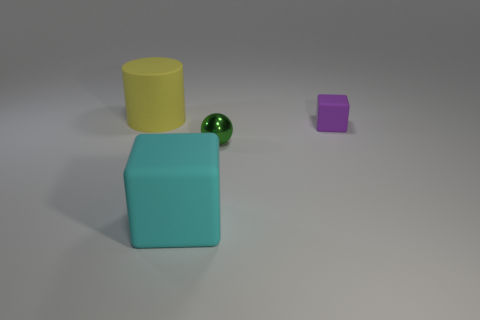Subtract all purple blocks. How many blocks are left? 1 Add 3 large matte things. How many objects exist? 7 Subtract all cylinders. How many objects are left? 3 Add 3 matte objects. How many matte objects are left? 6 Add 1 big gray metallic things. How many big gray metallic things exist? 1 Subtract 0 cyan cylinders. How many objects are left? 4 Subtract all gray cubes. Subtract all blue cylinders. How many cubes are left? 2 Subtract all tiny metal spheres. Subtract all big cyan rubber objects. How many objects are left? 2 